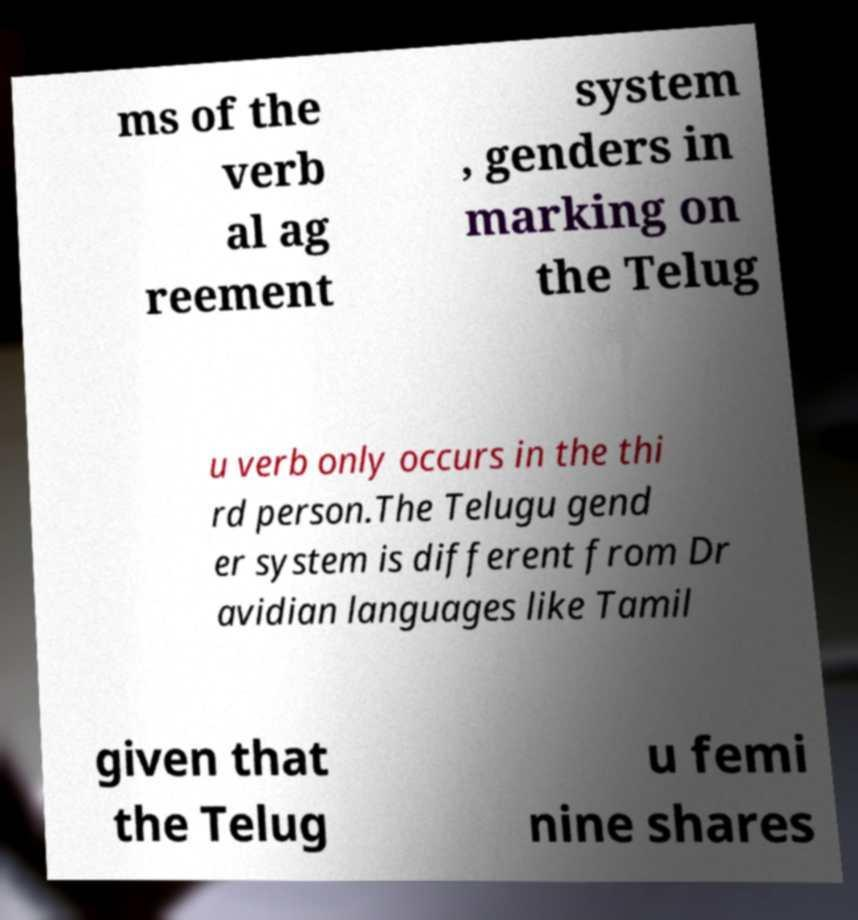Please identify and transcribe the text found in this image. ms of the verb al ag reement system , genders in marking on the Telug u verb only occurs in the thi rd person.The Telugu gend er system is different from Dr avidian languages like Tamil given that the Telug u femi nine shares 